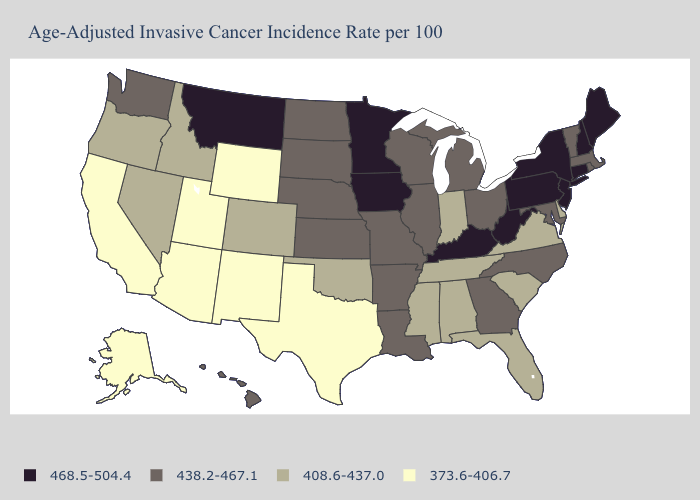Does Nevada have the highest value in the USA?
Short answer required. No. What is the lowest value in states that border North Carolina?
Give a very brief answer. 408.6-437.0. Does Maryland have a lower value than Connecticut?
Quick response, please. Yes. Name the states that have a value in the range 438.2-467.1?
Write a very short answer. Arkansas, Georgia, Hawaii, Illinois, Kansas, Louisiana, Maryland, Massachusetts, Michigan, Missouri, Nebraska, North Carolina, North Dakota, Ohio, Rhode Island, South Dakota, Vermont, Washington, Wisconsin. Name the states that have a value in the range 373.6-406.7?
Quick response, please. Alaska, Arizona, California, New Mexico, Texas, Utah, Wyoming. Name the states that have a value in the range 438.2-467.1?
Short answer required. Arkansas, Georgia, Hawaii, Illinois, Kansas, Louisiana, Maryland, Massachusetts, Michigan, Missouri, Nebraska, North Carolina, North Dakota, Ohio, Rhode Island, South Dakota, Vermont, Washington, Wisconsin. Name the states that have a value in the range 373.6-406.7?
Keep it brief. Alaska, Arizona, California, New Mexico, Texas, Utah, Wyoming. Name the states that have a value in the range 438.2-467.1?
Write a very short answer. Arkansas, Georgia, Hawaii, Illinois, Kansas, Louisiana, Maryland, Massachusetts, Michigan, Missouri, Nebraska, North Carolina, North Dakota, Ohio, Rhode Island, South Dakota, Vermont, Washington, Wisconsin. Name the states that have a value in the range 438.2-467.1?
Short answer required. Arkansas, Georgia, Hawaii, Illinois, Kansas, Louisiana, Maryland, Massachusetts, Michigan, Missouri, Nebraska, North Carolina, North Dakota, Ohio, Rhode Island, South Dakota, Vermont, Washington, Wisconsin. What is the value of Arkansas?
Quick response, please. 438.2-467.1. What is the highest value in the USA?
Keep it brief. 468.5-504.4. Is the legend a continuous bar?
Short answer required. No. What is the value of North Carolina?
Give a very brief answer. 438.2-467.1. Name the states that have a value in the range 468.5-504.4?
Keep it brief. Connecticut, Iowa, Kentucky, Maine, Minnesota, Montana, New Hampshire, New Jersey, New York, Pennsylvania, West Virginia. Name the states that have a value in the range 438.2-467.1?
Short answer required. Arkansas, Georgia, Hawaii, Illinois, Kansas, Louisiana, Maryland, Massachusetts, Michigan, Missouri, Nebraska, North Carolina, North Dakota, Ohio, Rhode Island, South Dakota, Vermont, Washington, Wisconsin. 